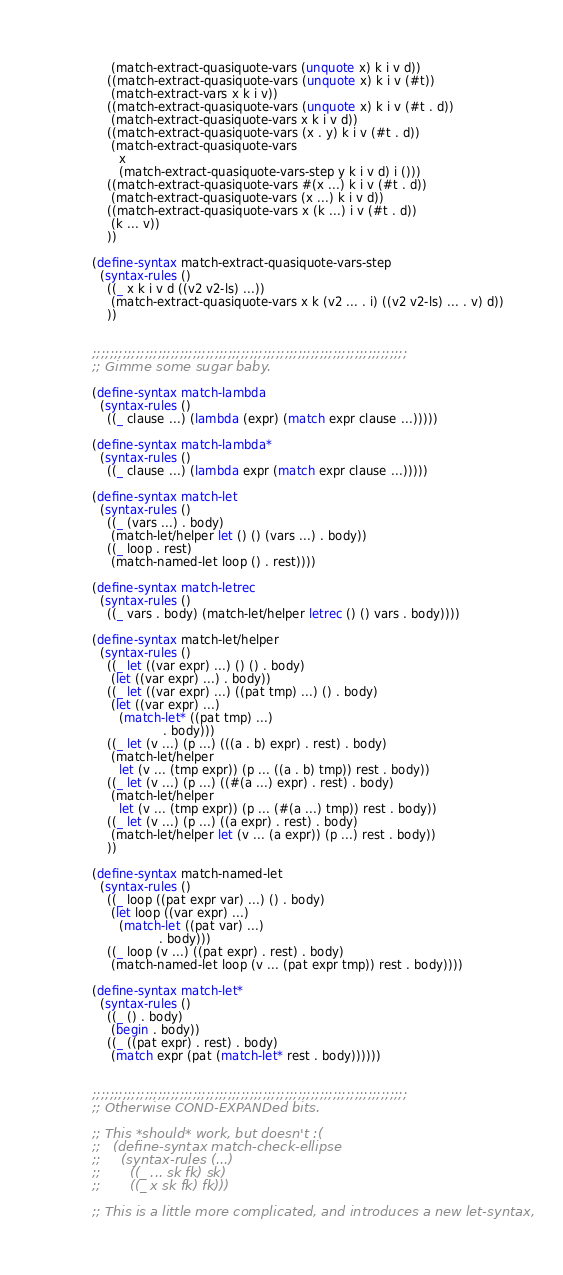<code> <loc_0><loc_0><loc_500><loc_500><_Scheme_>              (match-extract-quasiquote-vars (unquote x) k i v d))
             ((match-extract-quasiquote-vars (unquote x) k i v (#t))
              (match-extract-vars x k i v))
             ((match-extract-quasiquote-vars (unquote x) k i v (#t . d))
              (match-extract-quasiquote-vars x k i v d))
             ((match-extract-quasiquote-vars (x . y) k i v (#t . d))
              (match-extract-quasiquote-vars
                x
                (match-extract-quasiquote-vars-step y k i v d) i ()))
             ((match-extract-quasiquote-vars #(x ...) k i v (#t . d))
              (match-extract-quasiquote-vars (x ...) k i v d))
             ((match-extract-quasiquote-vars x (k ...) i v (#t . d))
              (k ... v))
             ))

         (define-syntax match-extract-quasiquote-vars-step
           (syntax-rules ()
             ((_ x k i v d ((v2 v2-ls) ...))
              (match-extract-quasiquote-vars x k (v2 ... . i) ((v2 v2-ls) ... . v) d))
             ))


         ;;;;;;;;;;;;;;;;;;;;;;;;;;;;;;;;;;;;;;;;;;;;;;;;;;;;;;;;;;;;;;;;;;;;;;;;
         ;; Gimme some sugar baby.

         (define-syntax match-lambda
           (syntax-rules ()
             ((_ clause ...) (lambda (expr) (match expr clause ...)))))

         (define-syntax match-lambda*
           (syntax-rules ()
             ((_ clause ...) (lambda expr (match expr clause ...)))))

         (define-syntax match-let
           (syntax-rules ()
             ((_ (vars ...) . body)
              (match-let/helper let () () (vars ...) . body))
             ((_ loop . rest)
              (match-named-let loop () . rest))))

         (define-syntax match-letrec
           (syntax-rules ()
             ((_ vars . body) (match-let/helper letrec () () vars . body))))

         (define-syntax match-let/helper
           (syntax-rules ()
             ((_ let ((var expr) ...) () () . body)
              (let ((var expr) ...) . body))
             ((_ let ((var expr) ...) ((pat tmp) ...) () . body)
              (let ((var expr) ...)
                (match-let* ((pat tmp) ...)
                            . body)))
             ((_ let (v ...) (p ...) (((a . b) expr) . rest) . body)
              (match-let/helper
                let (v ... (tmp expr)) (p ... ((a . b) tmp)) rest . body))
             ((_ let (v ...) (p ...) ((#(a ...) expr) . rest) . body)
              (match-let/helper
                let (v ... (tmp expr)) (p ... (#(a ...) tmp)) rest . body))
             ((_ let (v ...) (p ...) ((a expr) . rest) . body)
              (match-let/helper let (v ... (a expr)) (p ...) rest . body))
             ))

         (define-syntax match-named-let
           (syntax-rules ()
             ((_ loop ((pat expr var) ...) () . body)
              (let loop ((var expr) ...)
                (match-let ((pat var) ...)
                           . body)))
             ((_ loop (v ...) ((pat expr) . rest) . body)
              (match-named-let loop (v ... (pat expr tmp)) rest . body))))

         (define-syntax match-let*
           (syntax-rules ()
             ((_ () . body)
              (begin . body))
             ((_ ((pat expr) . rest) . body)
              (match expr (pat (match-let* rest . body))))))


         ;;;;;;;;;;;;;;;;;;;;;;;;;;;;;;;;;;;;;;;;;;;;;;;;;;;;;;;;;;;;;;;;;;;;;;;;
         ;; Otherwise COND-EXPANDed bits.

         ;; This *should* work, but doesn't :(
         ;;   (define-syntax match-check-ellipse
         ;;     (syntax-rules (...)
         ;;       ((_ ... sk fk) sk)
         ;;       ((_ x sk fk) fk)))

         ;; This is a little more complicated, and introduces a new let-syntax,</code> 